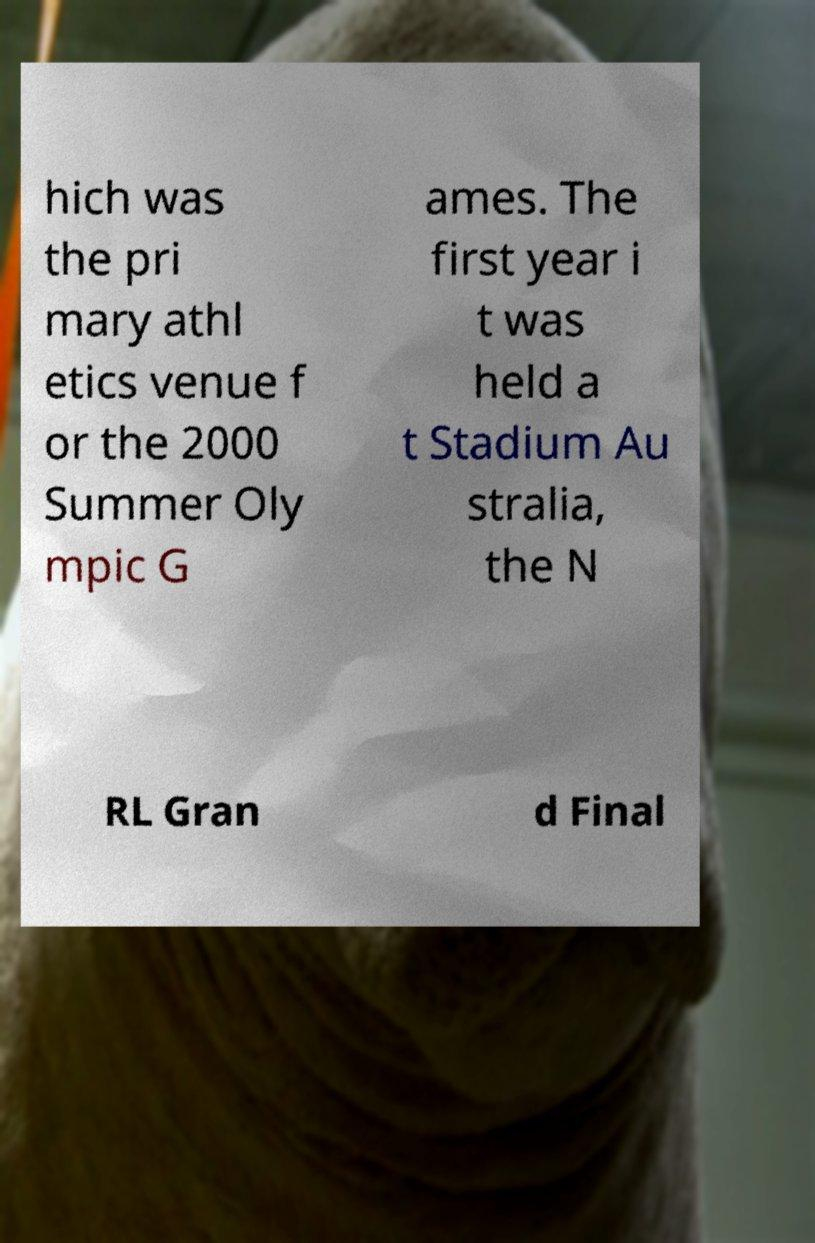Could you extract and type out the text from this image? hich was the pri mary athl etics venue f or the 2000 Summer Oly mpic G ames. The first year i t was held a t Stadium Au stralia, the N RL Gran d Final 